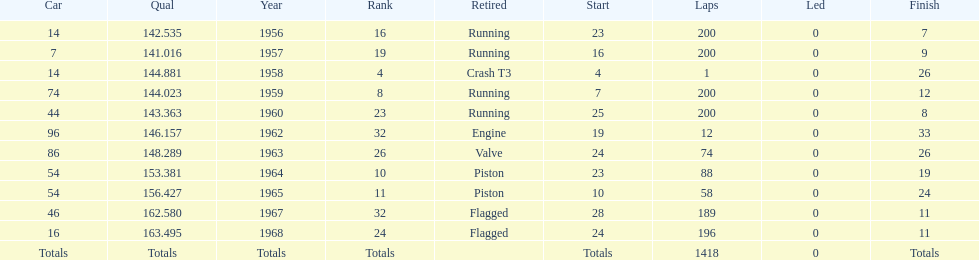How long did bob veith have the number 54 car at the indy 500? 2 years. 